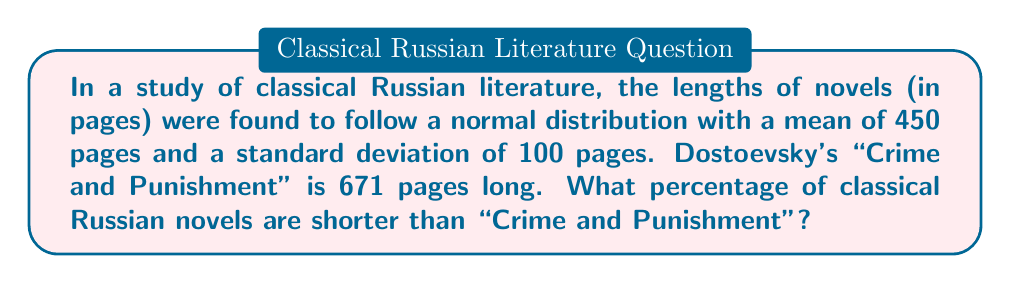Teach me how to tackle this problem. To solve this problem, we need to follow these steps:

1. Identify the given information:
   - The distribution of book lengths is normal
   - Mean (μ) = 450 pages
   - Standard deviation (σ) = 100 pages
   - "Crime and Punishment" length = 671 pages

2. Calculate the z-score for "Crime and Punishment":
   $$ z = \frac{x - μ}{σ} = \frac{671 - 450}{100} = 2.21 $$

3. Use a standard normal distribution table or calculator to find the area under the curve to the left of z = 2.21.

4. The area under the curve represents the probability of a book being shorter than "Crime and Punishment".

5. Using a z-table or calculator, we find that the area to the left of z = 2.21 is approximately 0.9864.

6. Convert this probability to a percentage:
   0.9864 * 100% = 98.64%

This result indicates that approximately 98.64% of classical Russian novels are shorter than "Crime and Punishment", reflecting Dostoevsky's tendency to write lengthy, complex works that often exceeded the typical length of his contemporaries.
Answer: 98.64% 